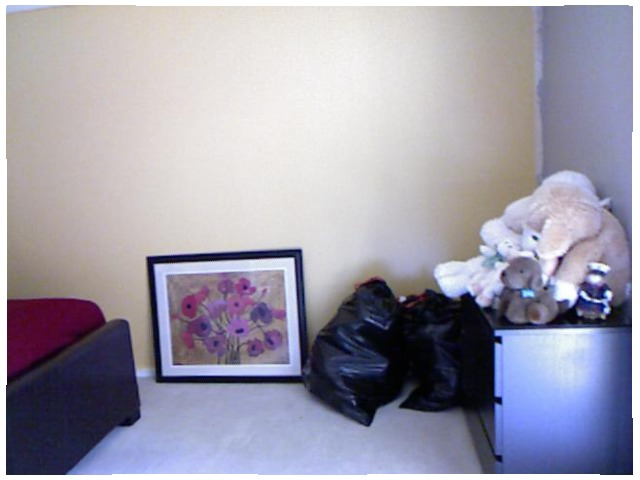<image>
Is there a portrait on the wall? No. The portrait is not positioned on the wall. They may be near each other, but the portrait is not supported by or resting on top of the wall. Is there a picture behind the bed? No. The picture is not behind the bed. From this viewpoint, the picture appears to be positioned elsewhere in the scene. 